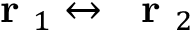Convert formula to latex. <formula><loc_0><loc_0><loc_500><loc_500>r _ { 1 } \leftrightarrow r _ { 2 }</formula> 